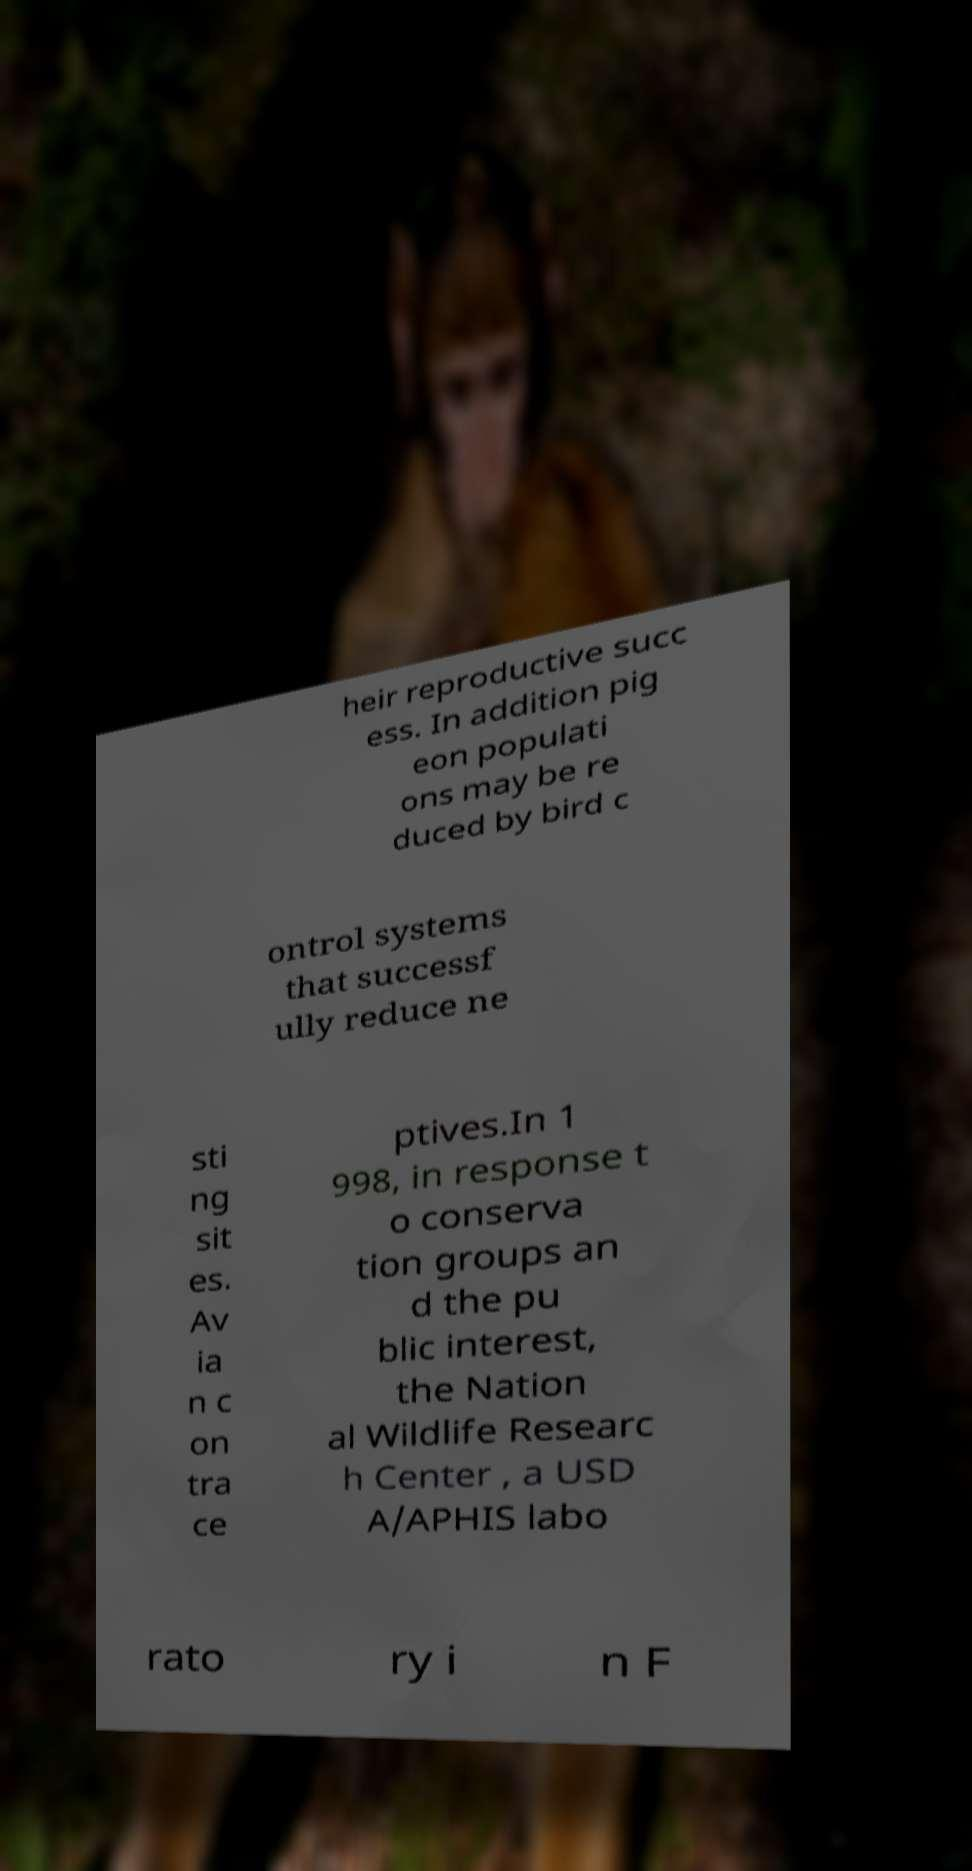There's text embedded in this image that I need extracted. Can you transcribe it verbatim? heir reproductive succ ess. In addition pig eon populati ons may be re duced by bird c ontrol systems that successf ully reduce ne sti ng sit es. Av ia n c on tra ce ptives.In 1 998, in response t o conserva tion groups an d the pu blic interest, the Nation al Wildlife Researc h Center , a USD A/APHIS labo rato ry i n F 